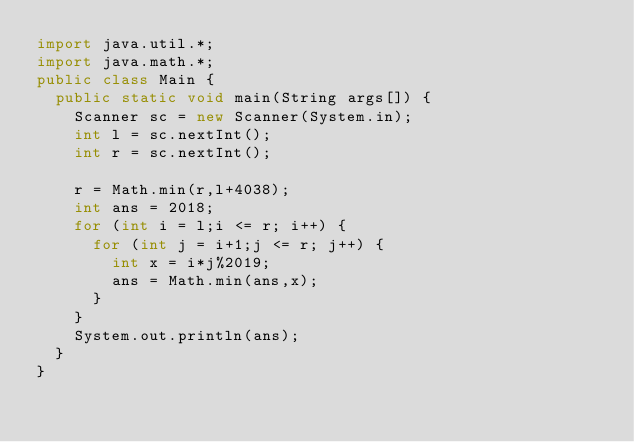Convert code to text. <code><loc_0><loc_0><loc_500><loc_500><_Java_>import java.util.*;
import java.math.*;
public class Main {
	public static void main(String args[]) {
		Scanner sc = new Scanner(System.in);
		int l = sc.nextInt();
		int r = sc.nextInt();
		
		r = Math.min(r,l+4038);
		int ans = 2018;
		for (int i = l;i <= r; i++) {
			for (int j = i+1;j <= r; j++) {
				int x = i*j%2019;
				ans = Math.min(ans,x);
			}
		}
		System.out.println(ans);
	}
}</code> 